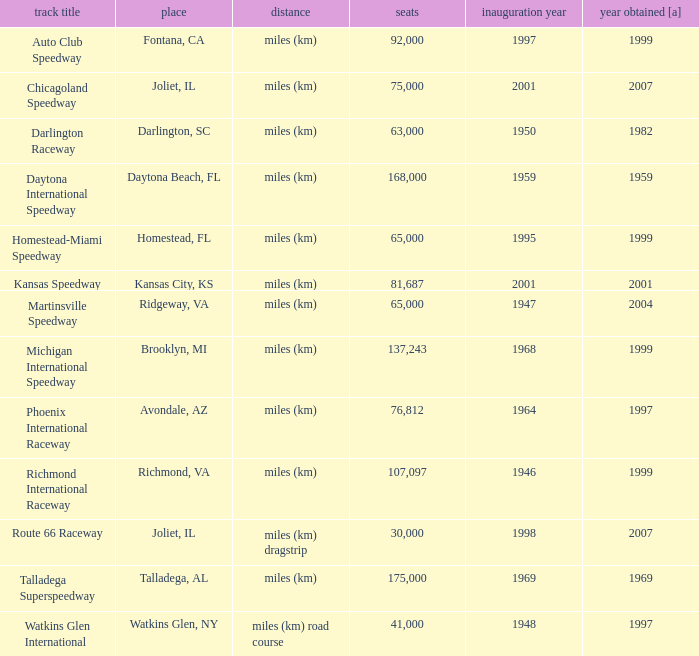What is the year opened for Chicagoland Speedway with a seating smaller than 75,000? None. 